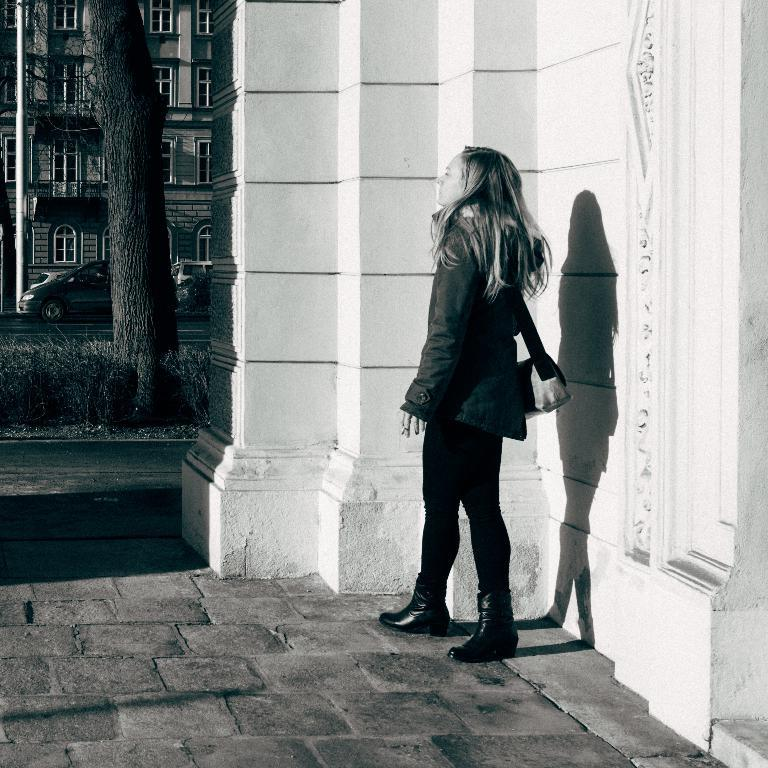What is the color scheme of the image? The image is black and white. What is the lady in the image doing? The lady is standing on a pavement. What can be seen in the background of the image? There are buildings, trees, and cars on a road in the background of the image. Can you see a patch of grass near the lady in the image? There is no patch of grass visible in the image. Is there a pipe visible in the image? There is no pipe present in the image. 